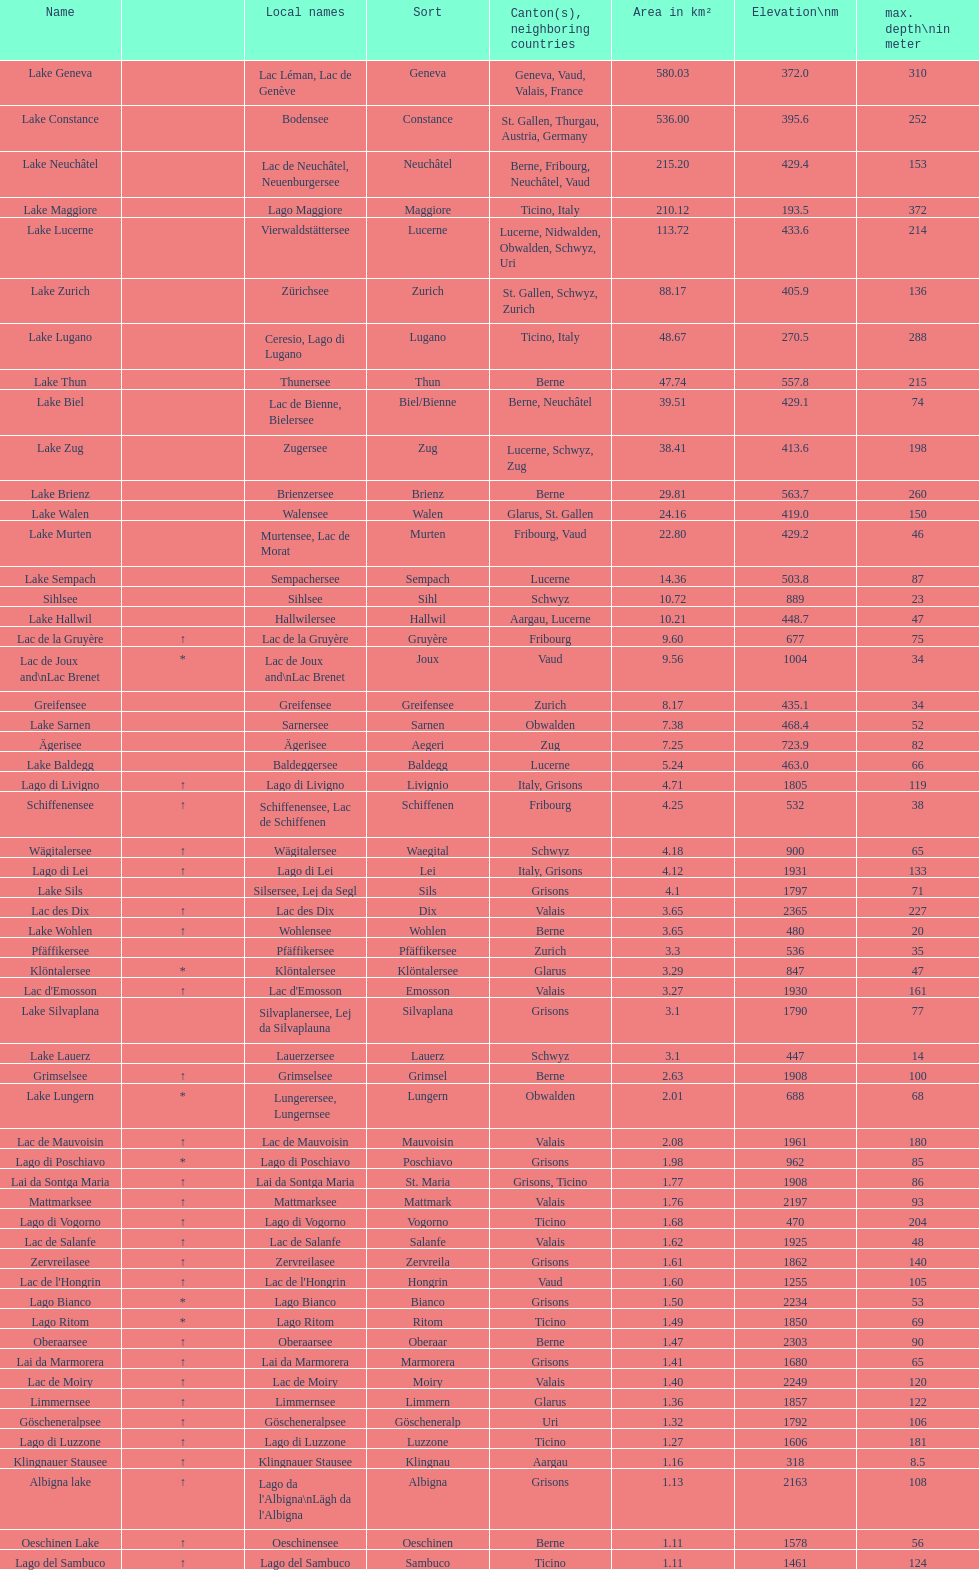Which lake has the maximum altitude? Lac des Dix. 